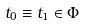Convert formula to latex. <formula><loc_0><loc_0><loc_500><loc_500>\, t _ { 0 } \equiv t _ { 1 } \in \Phi</formula> 